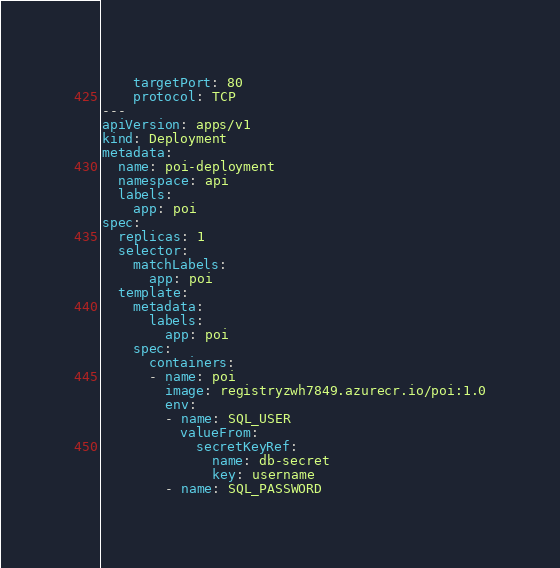<code> <loc_0><loc_0><loc_500><loc_500><_YAML_>    targetPort: 80
    protocol: TCP
---
apiVersion: apps/v1
kind: Deployment
metadata:
  name: poi-deployment
  namespace: api
  labels:
    app: poi
spec:
  replicas: 1
  selector:
    matchLabels:
      app: poi
  template:
    metadata:
      labels:
        app: poi
    spec:   
      containers:
      - name: poi
        image: registryzwh7849.azurecr.io/poi:1.0
        env:
        - name: SQL_USER
          valueFrom:
            secretKeyRef:
              name: db-secret
              key: username
        - name: SQL_PASSWORD</code> 